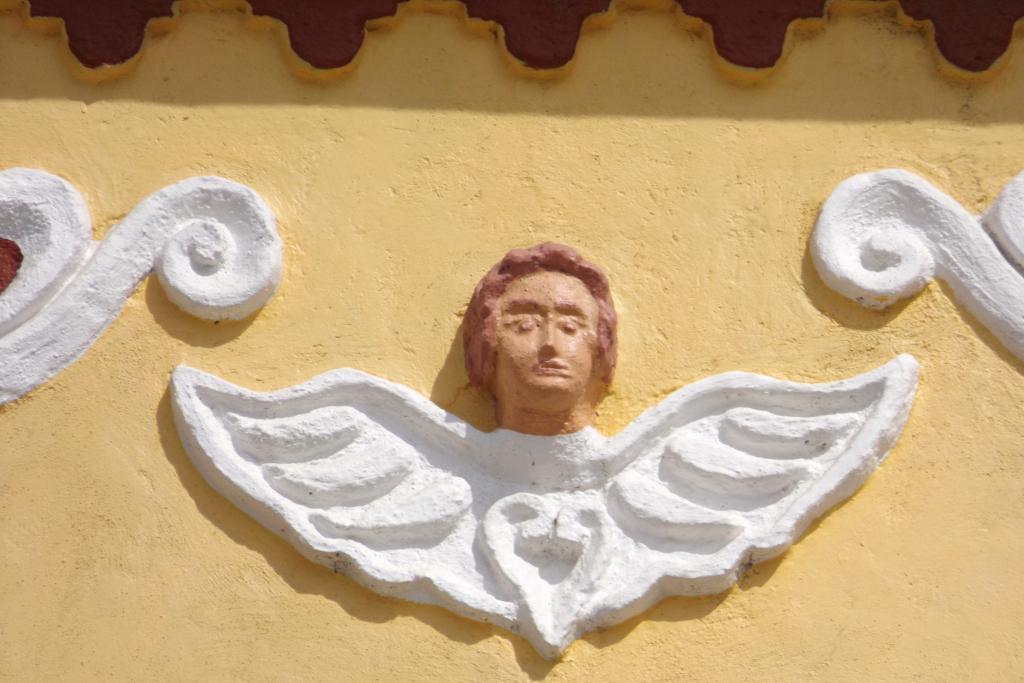Can you describe this image briefly? In this picture I can see carving on the wall. 